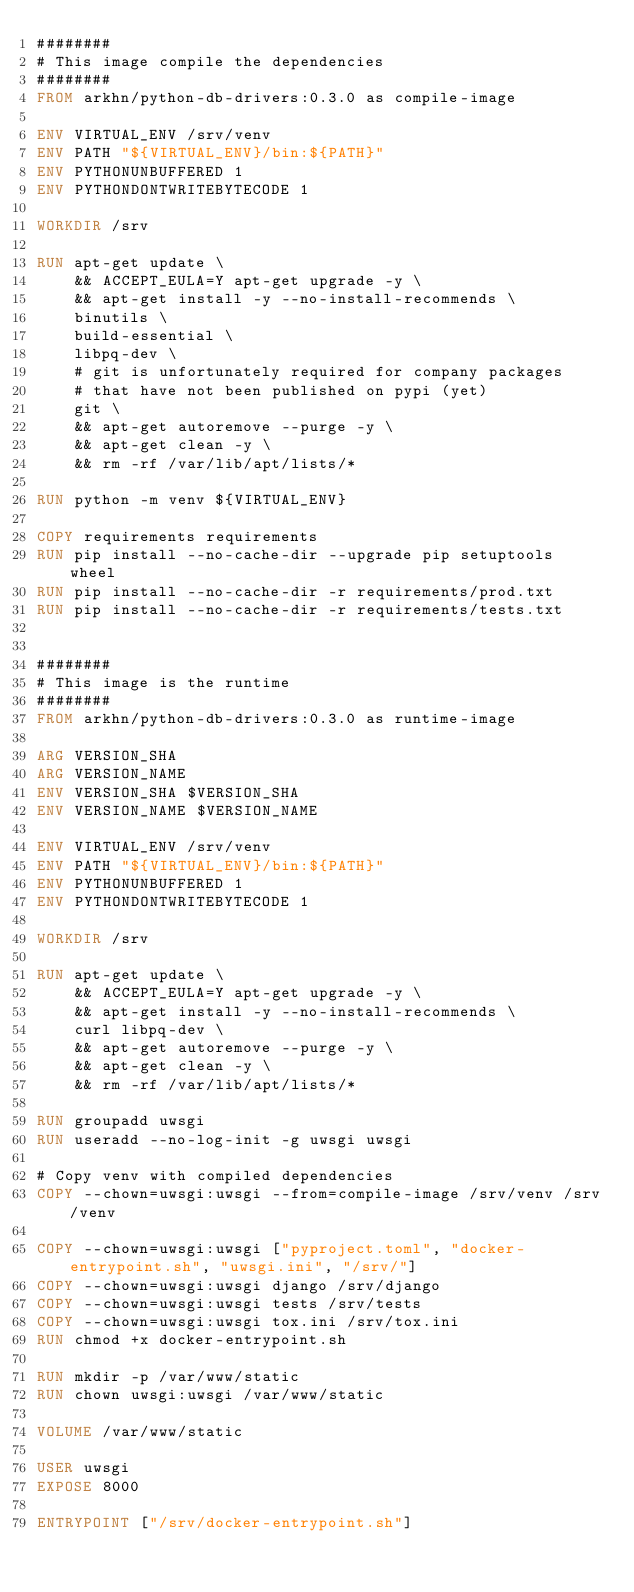<code> <loc_0><loc_0><loc_500><loc_500><_Dockerfile_>########
# This image compile the dependencies
########
FROM arkhn/python-db-drivers:0.3.0 as compile-image

ENV VIRTUAL_ENV /srv/venv
ENV PATH "${VIRTUAL_ENV}/bin:${PATH}"
ENV PYTHONUNBUFFERED 1
ENV PYTHONDONTWRITEBYTECODE 1

WORKDIR /srv

RUN apt-get update \
    && ACCEPT_EULA=Y apt-get upgrade -y \
    && apt-get install -y --no-install-recommends \
    binutils \
    build-essential \
    libpq-dev \
    # git is unfortunately required for company packages
    # that have not been published on pypi (yet)
    git \
    && apt-get autoremove --purge -y \
    && apt-get clean -y \
    && rm -rf /var/lib/apt/lists/*

RUN python -m venv ${VIRTUAL_ENV}

COPY requirements requirements
RUN pip install --no-cache-dir --upgrade pip setuptools wheel
RUN pip install --no-cache-dir -r requirements/prod.txt
RUN pip install --no-cache-dir -r requirements/tests.txt


########
# This image is the runtime
########
FROM arkhn/python-db-drivers:0.3.0 as runtime-image

ARG VERSION_SHA
ARG VERSION_NAME
ENV VERSION_SHA $VERSION_SHA
ENV VERSION_NAME $VERSION_NAME

ENV VIRTUAL_ENV /srv/venv
ENV PATH "${VIRTUAL_ENV}/bin:${PATH}"
ENV PYTHONUNBUFFERED 1
ENV PYTHONDONTWRITEBYTECODE 1

WORKDIR /srv

RUN apt-get update \
    && ACCEPT_EULA=Y apt-get upgrade -y \
    && apt-get install -y --no-install-recommends \
    curl libpq-dev \
    && apt-get autoremove --purge -y \
    && apt-get clean -y \
    && rm -rf /var/lib/apt/lists/*

RUN groupadd uwsgi
RUN useradd --no-log-init -g uwsgi uwsgi

# Copy venv with compiled dependencies
COPY --chown=uwsgi:uwsgi --from=compile-image /srv/venv /srv/venv

COPY --chown=uwsgi:uwsgi ["pyproject.toml", "docker-entrypoint.sh", "uwsgi.ini", "/srv/"]
COPY --chown=uwsgi:uwsgi django /srv/django
COPY --chown=uwsgi:uwsgi tests /srv/tests
COPY --chown=uwsgi:uwsgi tox.ini /srv/tox.ini
RUN chmod +x docker-entrypoint.sh

RUN mkdir -p /var/www/static
RUN chown uwsgi:uwsgi /var/www/static

VOLUME /var/www/static

USER uwsgi
EXPOSE 8000

ENTRYPOINT ["/srv/docker-entrypoint.sh"]
</code> 